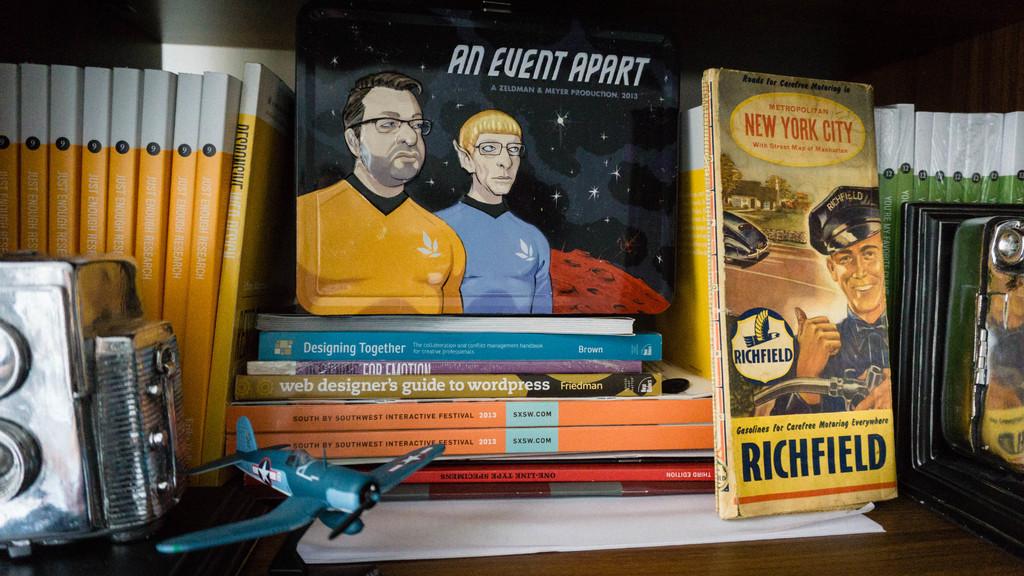What is the web designer's guide to?
Provide a succinct answer. Wordpress. 